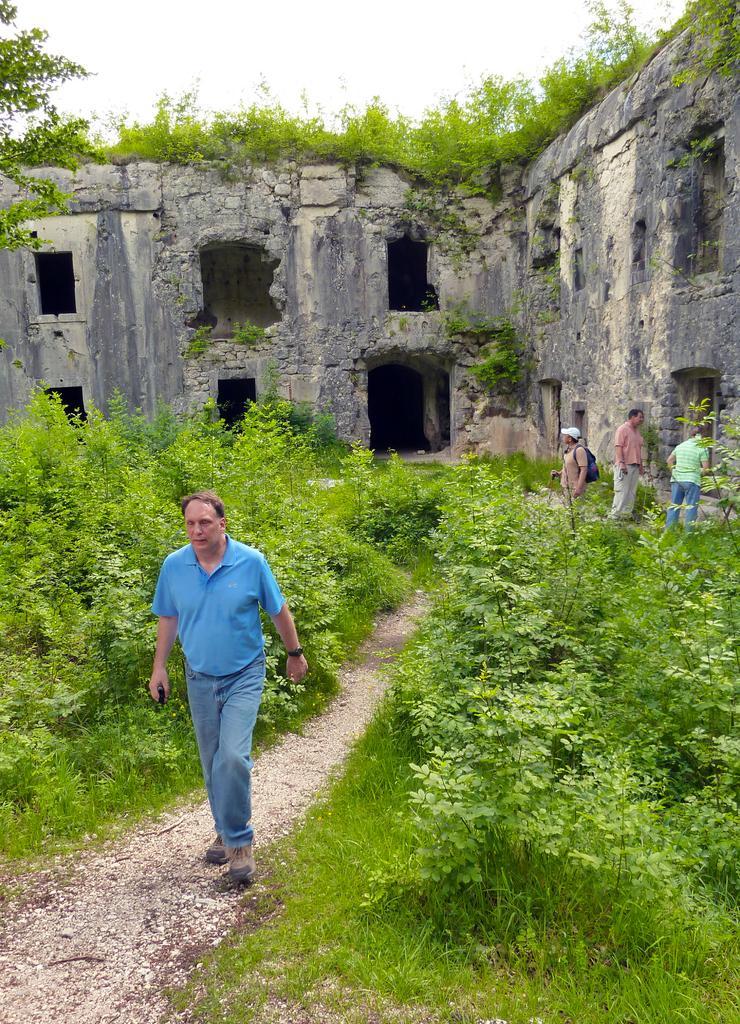Please provide a concise description of this image. In this image we can see a person walking on a small road. There are plants. In the back there is a building. And there are people. On the building there are plants. In the background there is sky. 